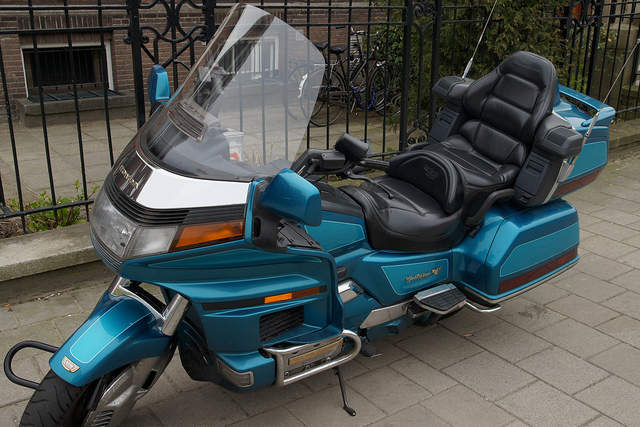Can you tell me more about the specific features visible on this motorcycle? Sure, this motorcycle is equipped with a number of features designed for comfort and utility. It has a large, protective windshield to reduce wind pressure on the riders. The seats are plush and contoured with backrests, indicating it's designed for long-distance touring. It also has saddlebags on either side for storage, highway pegs for a more relaxed leg position, and a full fairing to minimize air drag and protect the engine. 